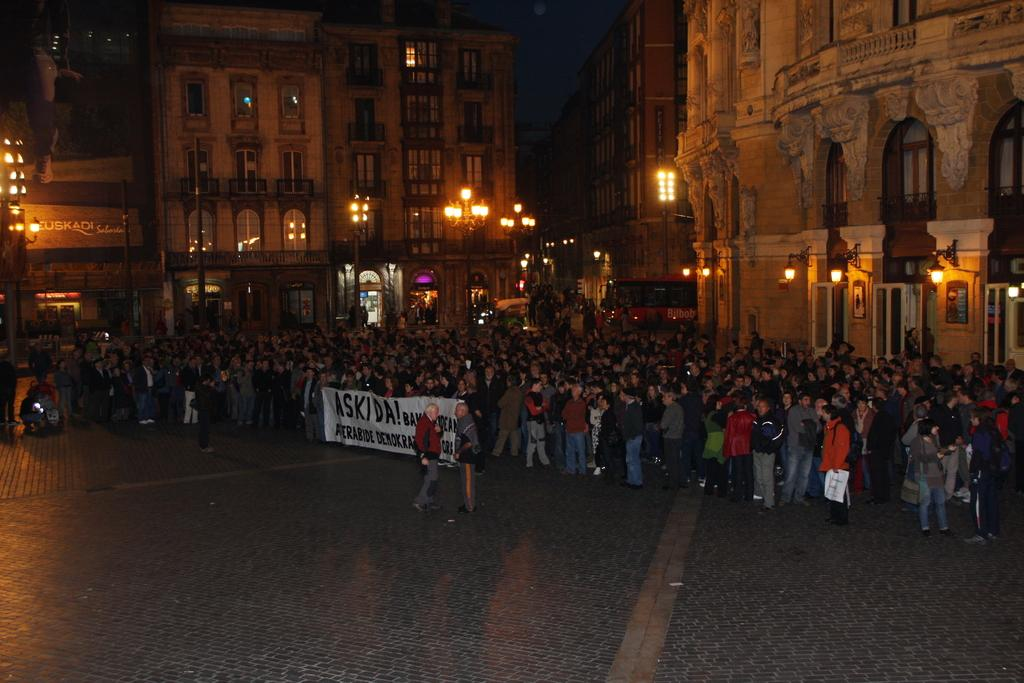What is happening in the image? There is a group of people standing in the image. What can be seen in the middle of the image? There is some text in the middle of the image. What is visible in the background of the image? There are buildings in the background of the image. Are there any cattle visible in the image? No, there are no cattle present in the image. Is there a fight happening between the people in the image? There is no indication of a fight in the image; the people are simply standing. 